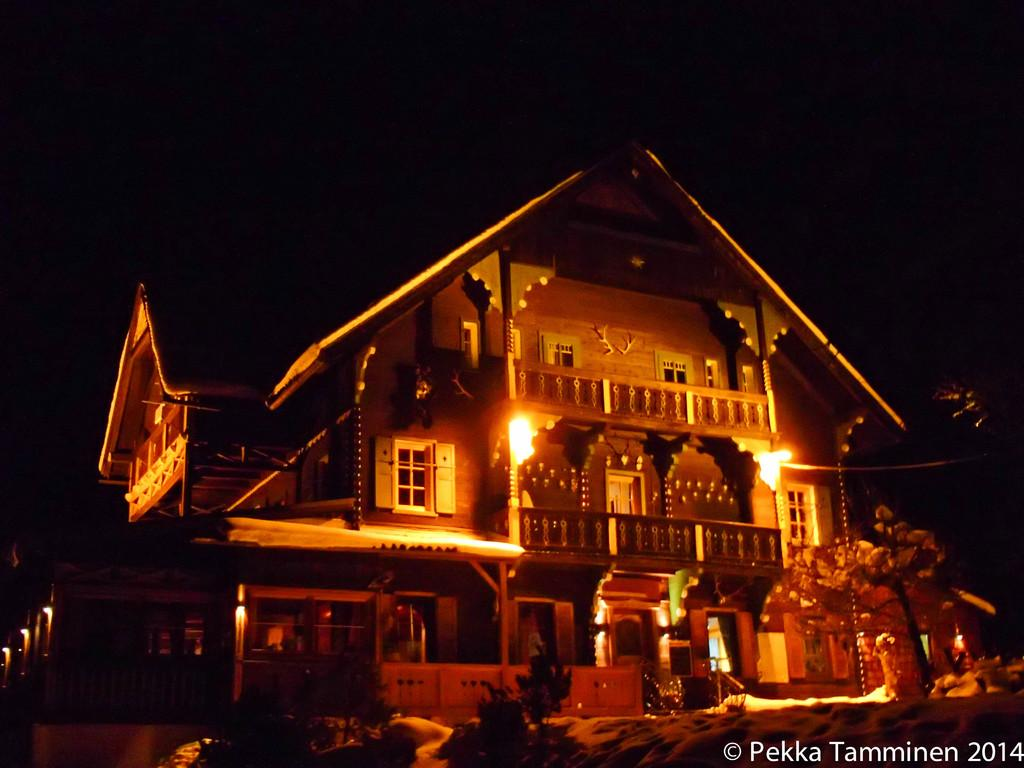What type of structure is visible in the image? There is a building in the image. What material is used for the railing on the building? The building has wood railing. What can be seen besides the building in the image? There is a group of poles and a group of trees in the foreground of the image. How many windows are visible on the building? There are windows on the building. What color is the crayon that the frog is holding in the image? There is no frog or crayon present in the image. What is the interest rate for the loan mentioned in the image? There is no mention of a loan or interest rate in the image. 